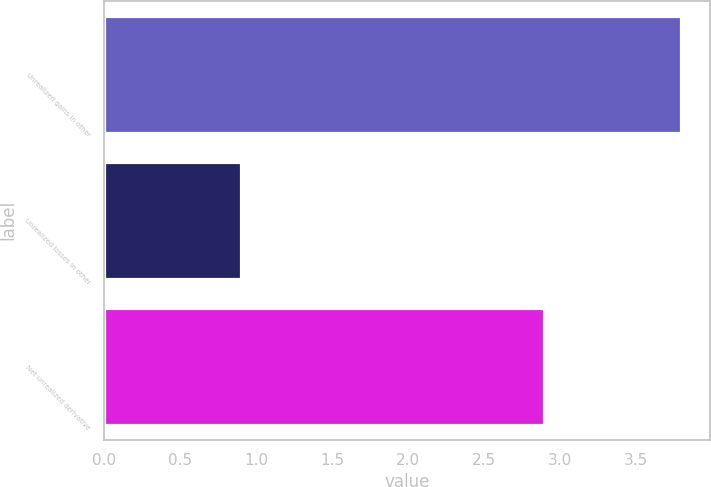Convert chart to OTSL. <chart><loc_0><loc_0><loc_500><loc_500><bar_chart><fcel>Unrealized gains in other<fcel>Unrealized losses in other<fcel>Net unrealized derivative<nl><fcel>3.8<fcel>0.9<fcel>2.9<nl></chart> 